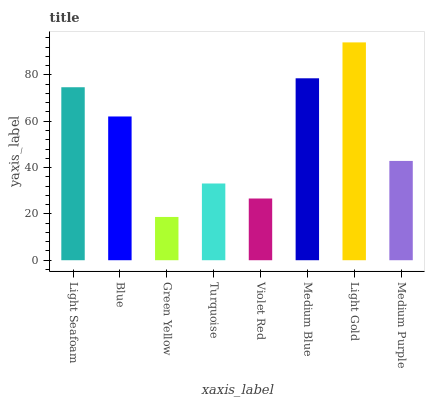Is Green Yellow the minimum?
Answer yes or no. Yes. Is Light Gold the maximum?
Answer yes or no. Yes. Is Blue the minimum?
Answer yes or no. No. Is Blue the maximum?
Answer yes or no. No. Is Light Seafoam greater than Blue?
Answer yes or no. Yes. Is Blue less than Light Seafoam?
Answer yes or no. Yes. Is Blue greater than Light Seafoam?
Answer yes or no. No. Is Light Seafoam less than Blue?
Answer yes or no. No. Is Blue the high median?
Answer yes or no. Yes. Is Medium Purple the low median?
Answer yes or no. Yes. Is Light Seafoam the high median?
Answer yes or no. No. Is Medium Blue the low median?
Answer yes or no. No. 